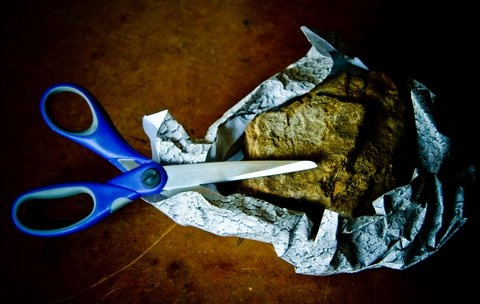Describe the objects in this image and their specific colors. I can see scissors in black, blue, lightblue, and darkblue tones in this image. 